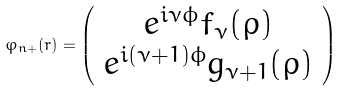<formula> <loc_0><loc_0><loc_500><loc_500>\varphi _ { n + } ( r ) = \left ( \begin{array} { c } e ^ { i \nu \phi } f _ { \nu } ( \rho ) \\ e ^ { i ( \nu + 1 ) \phi } g _ { \nu + 1 } ( \rho ) \end{array} \right )</formula> 